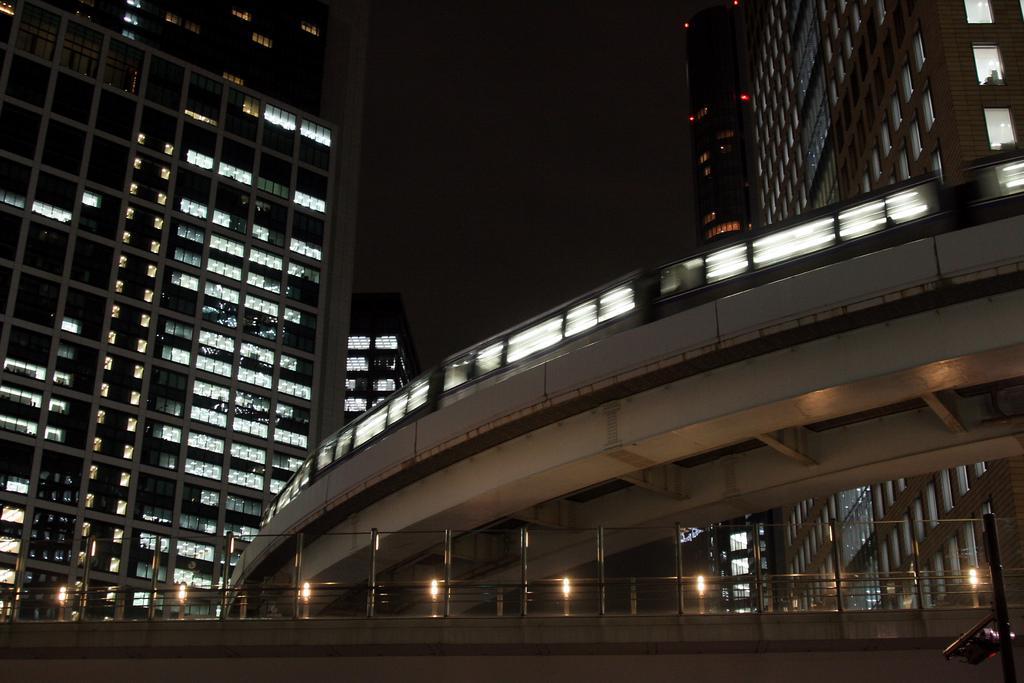In one or two sentences, can you explain what this image depicts? In this picture I can see buildings, lights, iron rods, this is looking like a train on the bridge. 